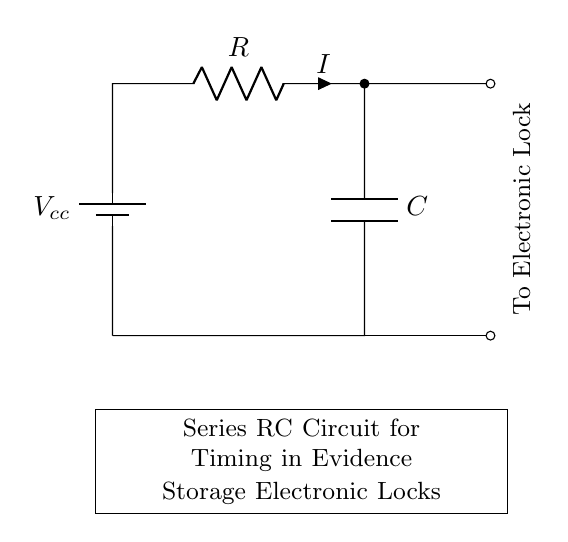What type of circuit is shown? The circuit is a series RC circuit, which consists of a resistor and a capacitor connected in series. This is indicated by the arrangement of the resistor and the capacitor in the diagram.
Answer: Series RC circuit What components are present in the circuit? The circuit contains a resistor and a capacitor. This can be identified by their respective symbols labeled in the diagram as R and C.
Answer: Resistor and capacitor What is the current flow direction in the circuit? The current flows from the positive terminal of the battery through the resistor, then through the capacitor, and back to the battery's negative terminal. This is deduced from the conventional direction of current flow and the connected components.
Answer: Clockwise What is the purpose of the capacitor in this circuit? The capacitor serves to store charge and create a timing effect in the circuit. This is because the charging and discharging of the capacitor determines how long the circuit will take to respond, which is essential for timing applications in electronic locks.
Answer: Timing How does the resistance value affect the timing in this circuit? Increasing the resistance results in a longer time constant for the RC circuit, which means the capacitor charges more slowly, thus delaying the time before the electronic lock activates. This relationship follows the formula for the time constant, which is the product of resistance and capacitance.
Answer: Longer timing What happens if the capacitor is removed from the circuit? If the capacitor is removed, the circuit would no longer have a timing function since there would be no charge storage capability. The current would immediately pass through the resistor with no delay, causing the electronic lock to activate instantly without a timing mechanism.
Answer: No timing function 